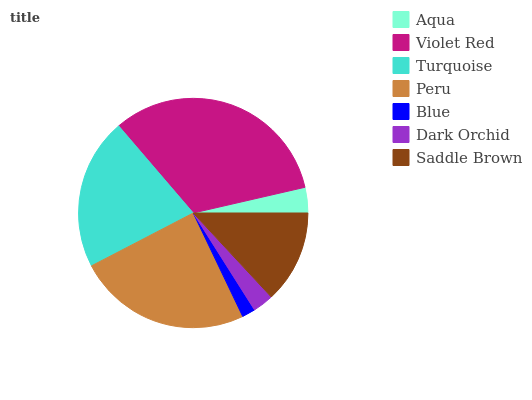Is Blue the minimum?
Answer yes or no. Yes. Is Violet Red the maximum?
Answer yes or no. Yes. Is Turquoise the minimum?
Answer yes or no. No. Is Turquoise the maximum?
Answer yes or no. No. Is Violet Red greater than Turquoise?
Answer yes or no. Yes. Is Turquoise less than Violet Red?
Answer yes or no. Yes. Is Turquoise greater than Violet Red?
Answer yes or no. No. Is Violet Red less than Turquoise?
Answer yes or no. No. Is Saddle Brown the high median?
Answer yes or no. Yes. Is Saddle Brown the low median?
Answer yes or no. Yes. Is Blue the high median?
Answer yes or no. No. Is Dark Orchid the low median?
Answer yes or no. No. 